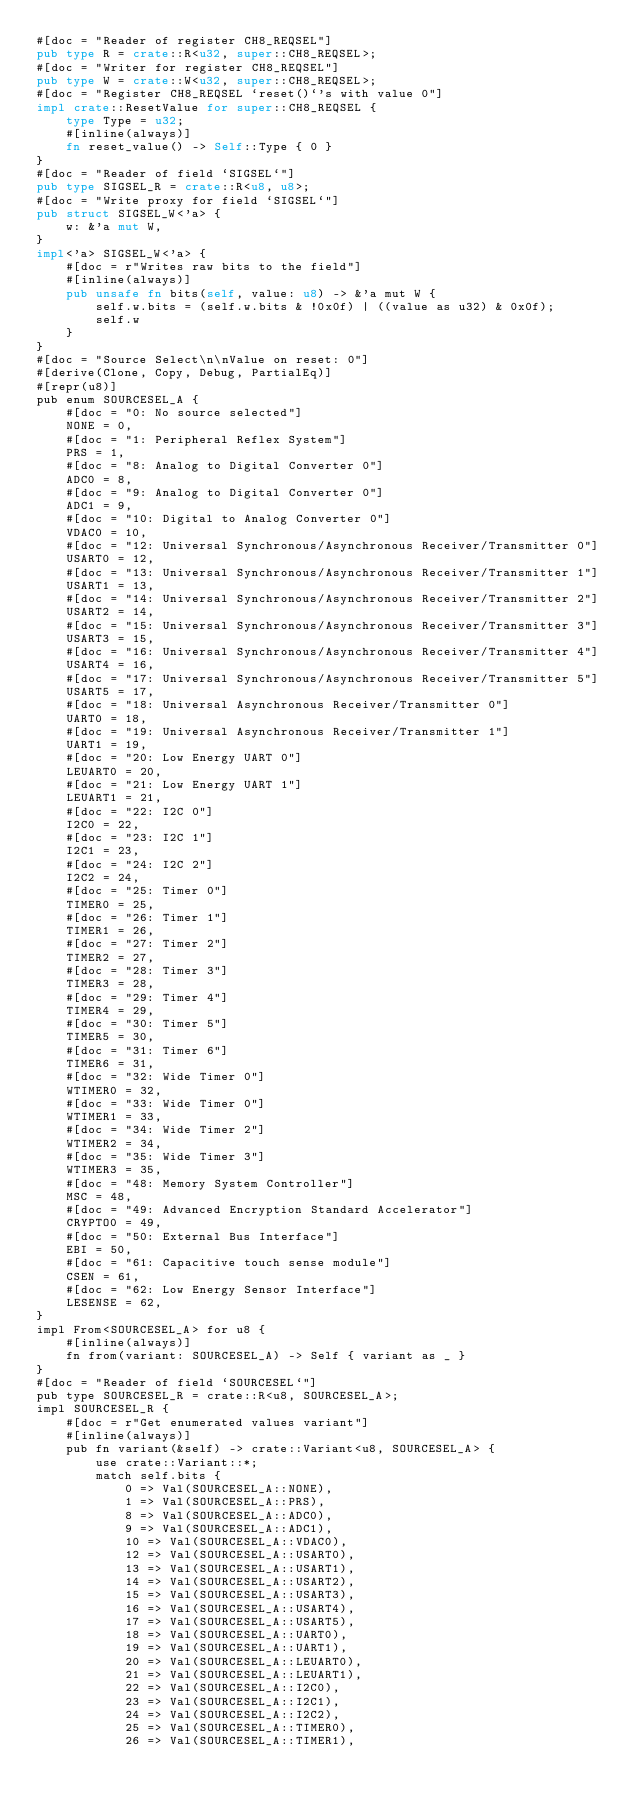Convert code to text. <code><loc_0><loc_0><loc_500><loc_500><_Rust_>#[doc = "Reader of register CH8_REQSEL"]
pub type R = crate::R<u32, super::CH8_REQSEL>;
#[doc = "Writer for register CH8_REQSEL"]
pub type W = crate::W<u32, super::CH8_REQSEL>;
#[doc = "Register CH8_REQSEL `reset()`'s with value 0"]
impl crate::ResetValue for super::CH8_REQSEL {
    type Type = u32;
    #[inline(always)]
    fn reset_value() -> Self::Type { 0 }
}
#[doc = "Reader of field `SIGSEL`"]
pub type SIGSEL_R = crate::R<u8, u8>;
#[doc = "Write proxy for field `SIGSEL`"]
pub struct SIGSEL_W<'a> {
    w: &'a mut W,
}
impl<'a> SIGSEL_W<'a> {
    #[doc = r"Writes raw bits to the field"]
    #[inline(always)]
    pub unsafe fn bits(self, value: u8) -> &'a mut W {
        self.w.bits = (self.w.bits & !0x0f) | ((value as u32) & 0x0f);
        self.w
    }
}
#[doc = "Source Select\n\nValue on reset: 0"]
#[derive(Clone, Copy, Debug, PartialEq)]
#[repr(u8)]
pub enum SOURCESEL_A {
    #[doc = "0: No source selected"]
    NONE = 0,
    #[doc = "1: Peripheral Reflex System"]
    PRS = 1,
    #[doc = "8: Analog to Digital Converter 0"]
    ADC0 = 8,
    #[doc = "9: Analog to Digital Converter 0"]
    ADC1 = 9,
    #[doc = "10: Digital to Analog Converter 0"]
    VDAC0 = 10,
    #[doc = "12: Universal Synchronous/Asynchronous Receiver/Transmitter 0"]
    USART0 = 12,
    #[doc = "13: Universal Synchronous/Asynchronous Receiver/Transmitter 1"]
    USART1 = 13,
    #[doc = "14: Universal Synchronous/Asynchronous Receiver/Transmitter 2"]
    USART2 = 14,
    #[doc = "15: Universal Synchronous/Asynchronous Receiver/Transmitter 3"]
    USART3 = 15,
    #[doc = "16: Universal Synchronous/Asynchronous Receiver/Transmitter 4"]
    USART4 = 16,
    #[doc = "17: Universal Synchronous/Asynchronous Receiver/Transmitter 5"]
    USART5 = 17,
    #[doc = "18: Universal Asynchronous Receiver/Transmitter 0"]
    UART0 = 18,
    #[doc = "19: Universal Asynchronous Receiver/Transmitter 1"]
    UART1 = 19,
    #[doc = "20: Low Energy UART 0"]
    LEUART0 = 20,
    #[doc = "21: Low Energy UART 1"]
    LEUART1 = 21,
    #[doc = "22: I2C 0"]
    I2C0 = 22,
    #[doc = "23: I2C 1"]
    I2C1 = 23,
    #[doc = "24: I2C 2"]
    I2C2 = 24,
    #[doc = "25: Timer 0"]
    TIMER0 = 25,
    #[doc = "26: Timer 1"]
    TIMER1 = 26,
    #[doc = "27: Timer 2"]
    TIMER2 = 27,
    #[doc = "28: Timer 3"]
    TIMER3 = 28,
    #[doc = "29: Timer 4"]
    TIMER4 = 29,
    #[doc = "30: Timer 5"]
    TIMER5 = 30,
    #[doc = "31: Timer 6"]
    TIMER6 = 31,
    #[doc = "32: Wide Timer 0"]
    WTIMER0 = 32,
    #[doc = "33: Wide Timer 0"]
    WTIMER1 = 33,
    #[doc = "34: Wide Timer 2"]
    WTIMER2 = 34,
    #[doc = "35: Wide Timer 3"]
    WTIMER3 = 35,
    #[doc = "48: Memory System Controller"]
    MSC = 48,
    #[doc = "49: Advanced Encryption Standard Accelerator"]
    CRYPTO0 = 49,
    #[doc = "50: External Bus Interface"]
    EBI = 50,
    #[doc = "61: Capacitive touch sense module"]
    CSEN = 61,
    #[doc = "62: Low Energy Sensor Interface"]
    LESENSE = 62,
}
impl From<SOURCESEL_A> for u8 {
    #[inline(always)]
    fn from(variant: SOURCESEL_A) -> Self { variant as _ }
}
#[doc = "Reader of field `SOURCESEL`"]
pub type SOURCESEL_R = crate::R<u8, SOURCESEL_A>;
impl SOURCESEL_R {
    #[doc = r"Get enumerated values variant"]
    #[inline(always)]
    pub fn variant(&self) -> crate::Variant<u8, SOURCESEL_A> {
        use crate::Variant::*;
        match self.bits {
            0 => Val(SOURCESEL_A::NONE),
            1 => Val(SOURCESEL_A::PRS),
            8 => Val(SOURCESEL_A::ADC0),
            9 => Val(SOURCESEL_A::ADC1),
            10 => Val(SOURCESEL_A::VDAC0),
            12 => Val(SOURCESEL_A::USART0),
            13 => Val(SOURCESEL_A::USART1),
            14 => Val(SOURCESEL_A::USART2),
            15 => Val(SOURCESEL_A::USART3),
            16 => Val(SOURCESEL_A::USART4),
            17 => Val(SOURCESEL_A::USART5),
            18 => Val(SOURCESEL_A::UART0),
            19 => Val(SOURCESEL_A::UART1),
            20 => Val(SOURCESEL_A::LEUART0),
            21 => Val(SOURCESEL_A::LEUART1),
            22 => Val(SOURCESEL_A::I2C0),
            23 => Val(SOURCESEL_A::I2C1),
            24 => Val(SOURCESEL_A::I2C2),
            25 => Val(SOURCESEL_A::TIMER0),
            26 => Val(SOURCESEL_A::TIMER1),</code> 